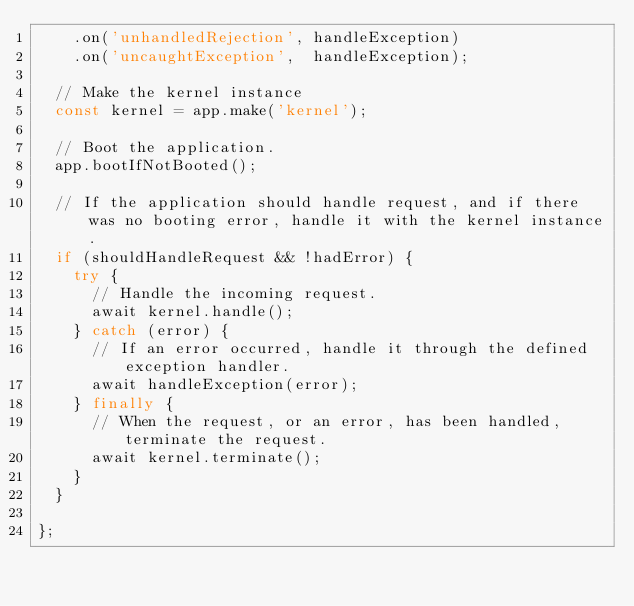Convert code to text. <code><loc_0><loc_0><loc_500><loc_500><_JavaScript_>		.on('unhandledRejection', handleException)
		.on('uncaughtException',  handleException);

	// Make the kernel instance
	const kernel = app.make('kernel');

	// Boot the application.
	app.bootIfNotBooted();

	// If the application should handle request, and if there was no booting error, handle it with the kernel instance.
	if (shouldHandleRequest && !hadError) {
		try {
			// Handle the incoming request.
			await kernel.handle();
		} catch (error) {
			// If an error occurred, handle it through the defined exception handler.
			await handleException(error);
		} finally {
			// When the request, or an error, has been handled, terminate the request.
			await kernel.terminate();
		}
	}

};
</code> 